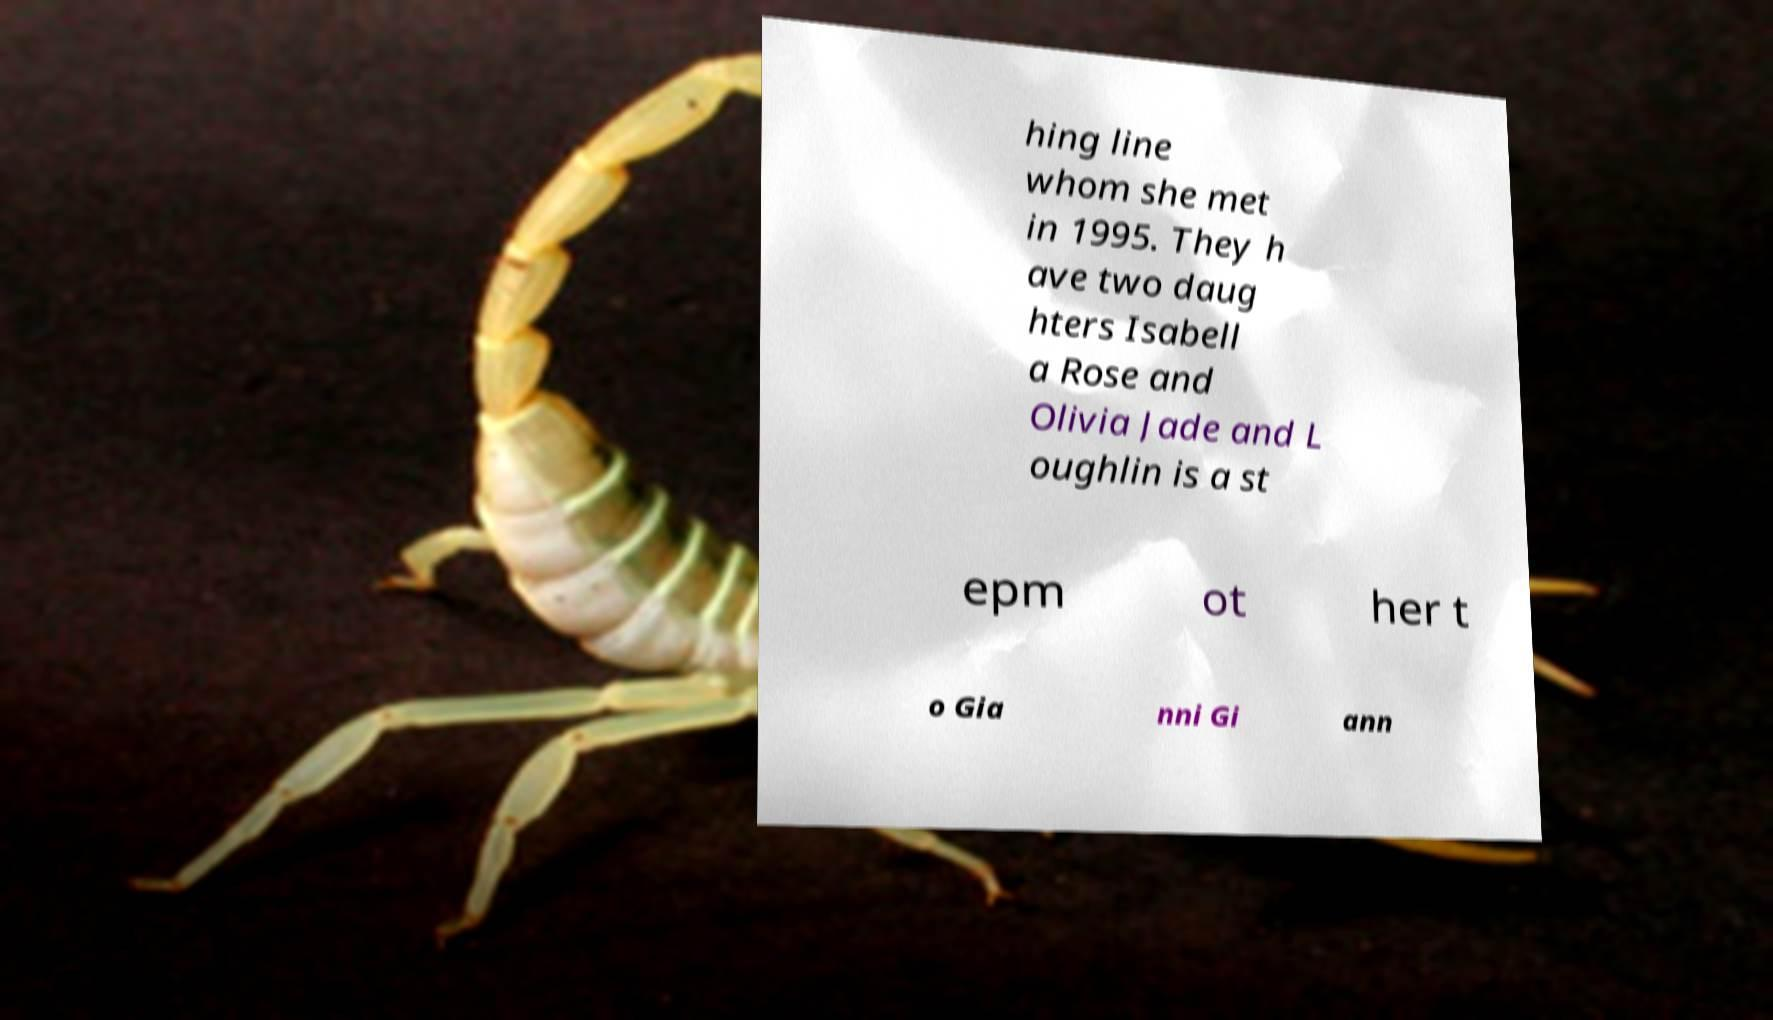Can you accurately transcribe the text from the provided image for me? hing line whom she met in 1995. They h ave two daug hters Isabell a Rose and Olivia Jade and L oughlin is a st epm ot her t o Gia nni Gi ann 